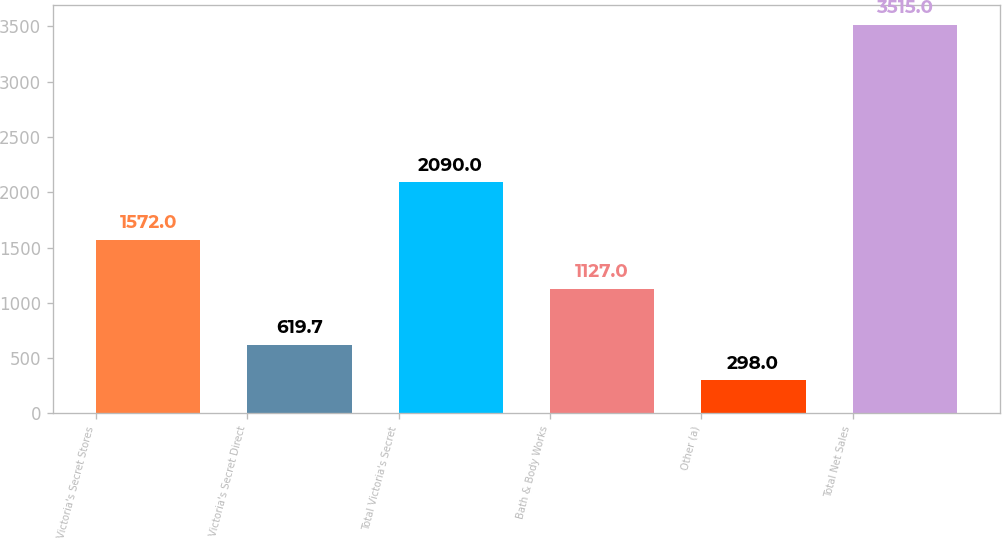<chart> <loc_0><loc_0><loc_500><loc_500><bar_chart><fcel>Victoria's Secret Stores<fcel>Victoria's Secret Direct<fcel>Total Victoria's Secret<fcel>Bath & Body Works<fcel>Other (a)<fcel>Total Net Sales<nl><fcel>1572<fcel>619.7<fcel>2090<fcel>1127<fcel>298<fcel>3515<nl></chart> 